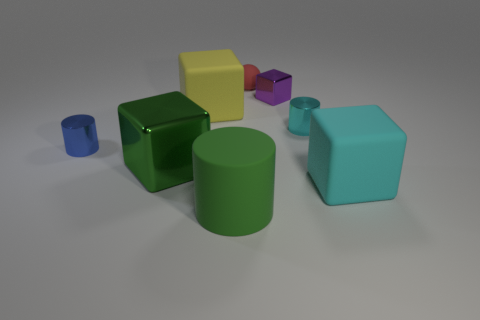Does the tiny metallic block have the same color as the large object that is in front of the large cyan matte block?
Offer a very short reply. No. There is a cube that is both on the right side of the large green cylinder and left of the cyan metal object; what material is it made of?
Your response must be concise. Metal. There is a metallic block that is the same color as the matte cylinder; what is its size?
Offer a very short reply. Large. There is a big rubber object that is to the right of the rubber cylinder; is it the same shape as the metal thing that is to the right of the purple cube?
Your answer should be compact. No. Are any big green shiny things visible?
Provide a short and direct response. Yes. The big matte thing that is the same shape as the tiny blue metal object is what color?
Your answer should be very brief. Green. There is a cylinder that is the same size as the green cube; what color is it?
Your answer should be very brief. Green. Do the tiny blue cylinder and the small cyan cylinder have the same material?
Ensure brevity in your answer.  Yes. What number of things have the same color as the matte cylinder?
Provide a short and direct response. 1. Do the small ball and the large shiny object have the same color?
Your response must be concise. No. 